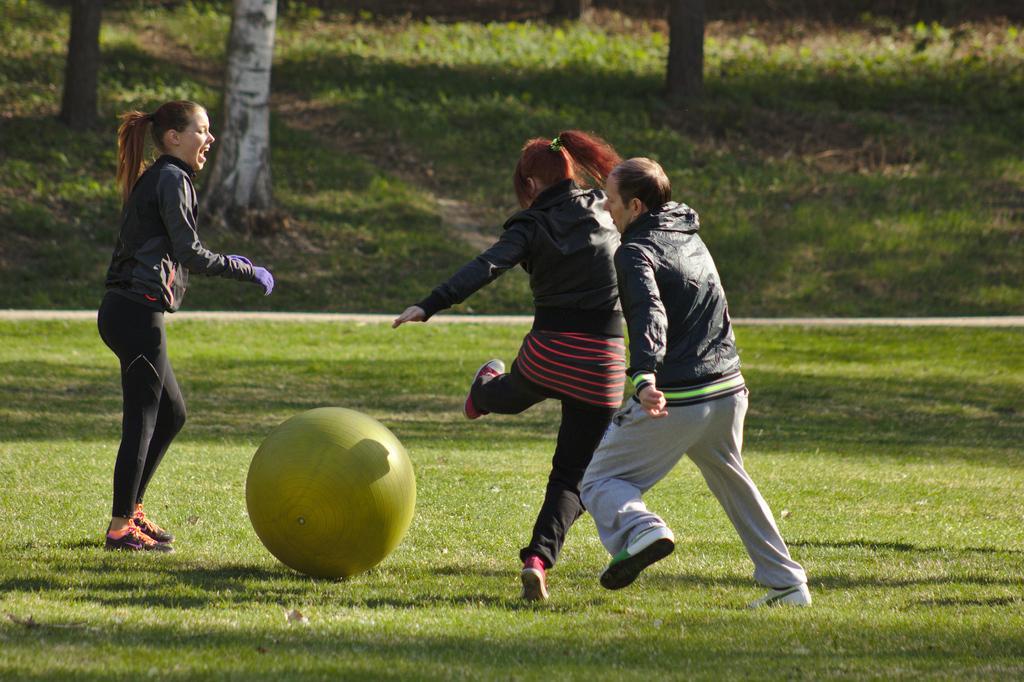Please provide a concise description of this image. In this image I can see there are persons playing with exercise ball. And there is a grass, Road and a trunk. 